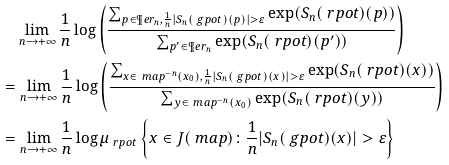Convert formula to latex. <formula><loc_0><loc_0><loc_500><loc_500>& \quad \lim _ { n \to + \infty } \frac { 1 } { n } \log \left ( \frac { \sum _ { { p \in \P e r _ { n } , \frac { 1 } { n } | S _ { n } ( \ g p o t ) ( p ) | > \varepsilon } } \exp ( S _ { n } ( \ r p o t ) ( p ) ) } { \sum _ { p ^ { \prime } \in \P e r _ { n } } \exp ( S _ { n } ( \ r p o t ) ( p ^ { \prime } ) ) } \right ) \\ & = \lim _ { n \to + \infty } \frac { 1 } { n } \log \left ( \frac { \sum _ { { x \in \ m a p ^ { - n } ( x _ { 0 } ) , \frac { 1 } { n } | S _ { n } ( \ g p o t ) ( x ) | > \varepsilon } } \exp ( S _ { n } ( \ r p o t ) ( x ) ) } { \sum _ { y \in \ m a p ^ { - n } ( x _ { 0 } ) } \exp ( S _ { n } ( \ r p o t ) ( y ) ) } \right ) \\ & = \lim _ { n \to + \infty } \frac { 1 } { n } \log \mu _ { \ r p o t } \left \{ x \in J ( \ m a p ) \colon \frac { 1 } { n } | S _ { n } ( \ g p o t ) ( x ) | > \varepsilon \right \}</formula> 